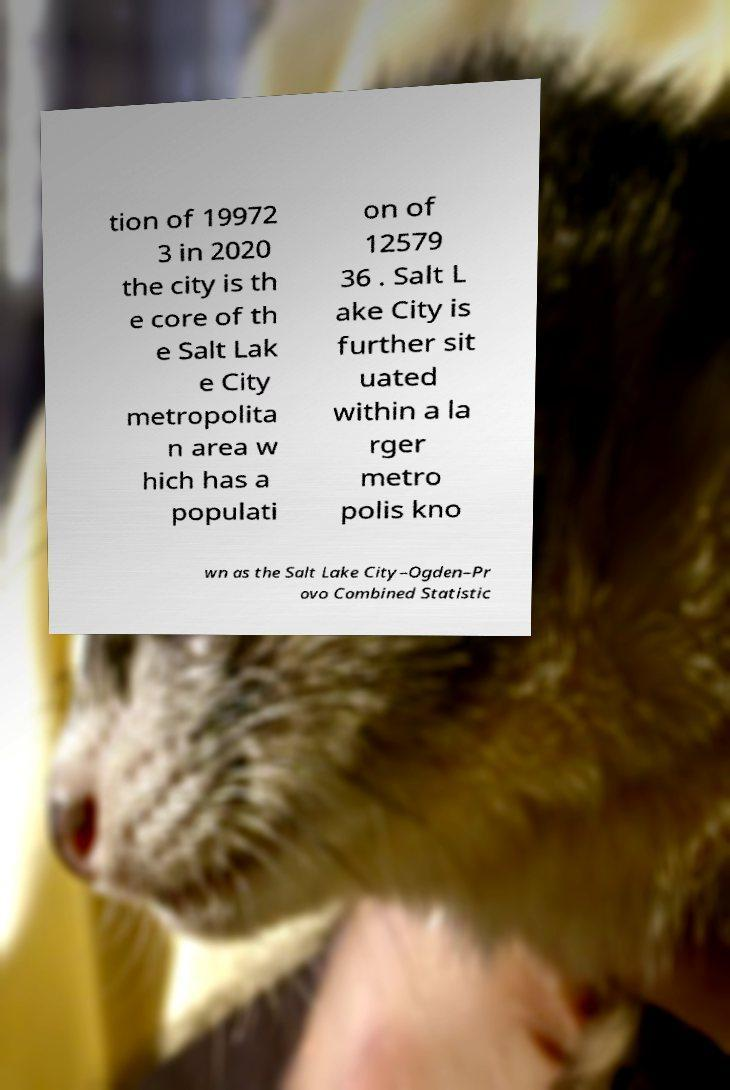I need the written content from this picture converted into text. Can you do that? tion of 19972 3 in 2020 the city is th e core of th e Salt Lak e City metropolita n area w hich has a populati on of 12579 36 . Salt L ake City is further sit uated within a la rger metro polis kno wn as the Salt Lake City–Ogden–Pr ovo Combined Statistic 